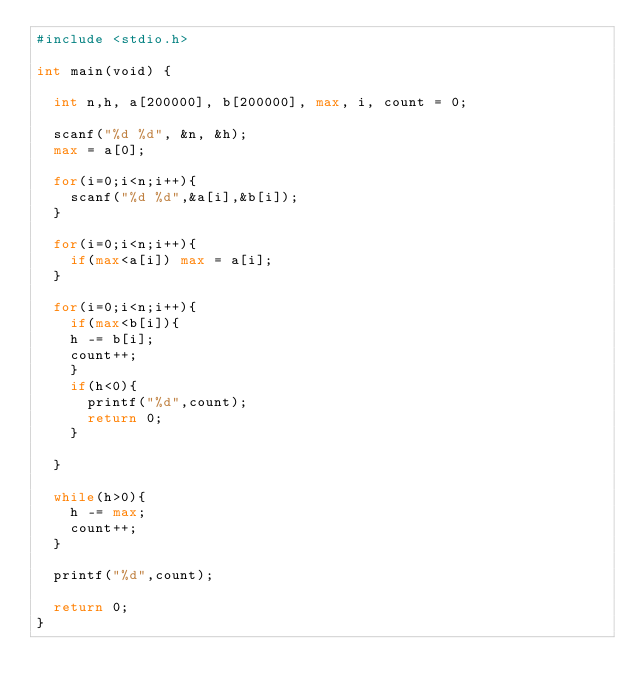<code> <loc_0><loc_0><loc_500><loc_500><_Python_>#include <stdio.h>

int main(void) {
	
	int n,h, a[200000], b[200000], max, i, count = 0;
	
	scanf("%d %d", &n, &h);
	max = a[0];
	
	for(i=0;i<n;i++){
		scanf("%d %d",&a[i],&b[i]);
	}
	
	for(i=0;i<n;i++){
		if(max<a[i]) max = a[i];
	}
	
	for(i=0;i<n;i++){
		if(max<b[i]){
		h -= b[i];
		count++;
		}
		if(h<0){
			printf("%d",count);
			return 0;
		}
			
	}

	while(h>0){
		h -= max;
		count++;
	}

	printf("%d",count);
	
	return 0;
}
</code> 